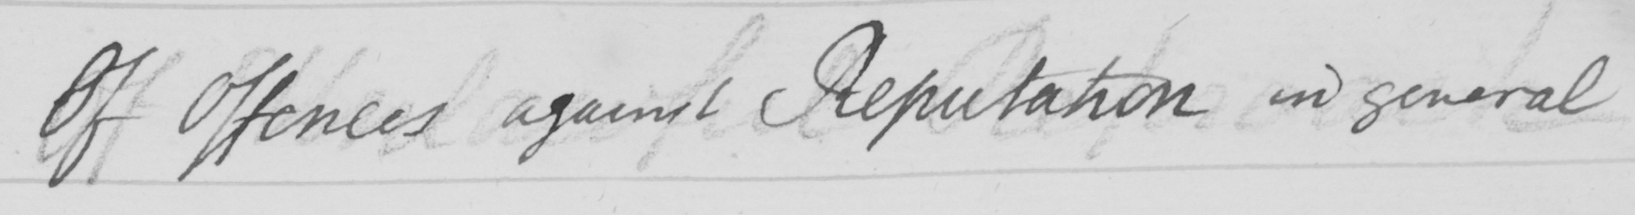Can you read and transcribe this handwriting? Of Offences against Reputation in general 